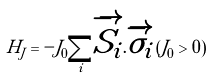Convert formula to latex. <formula><loc_0><loc_0><loc_500><loc_500>H _ { J } = - J _ { 0 } \underset { i } { \sum } \overrightarrow { S _ { i } } . \overrightarrow { \sigma _ { i } } \, ( J _ { 0 } > 0 )</formula> 